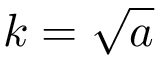Convert formula to latex. <formula><loc_0><loc_0><loc_500><loc_500>k = { \sqrt { a } }</formula> 